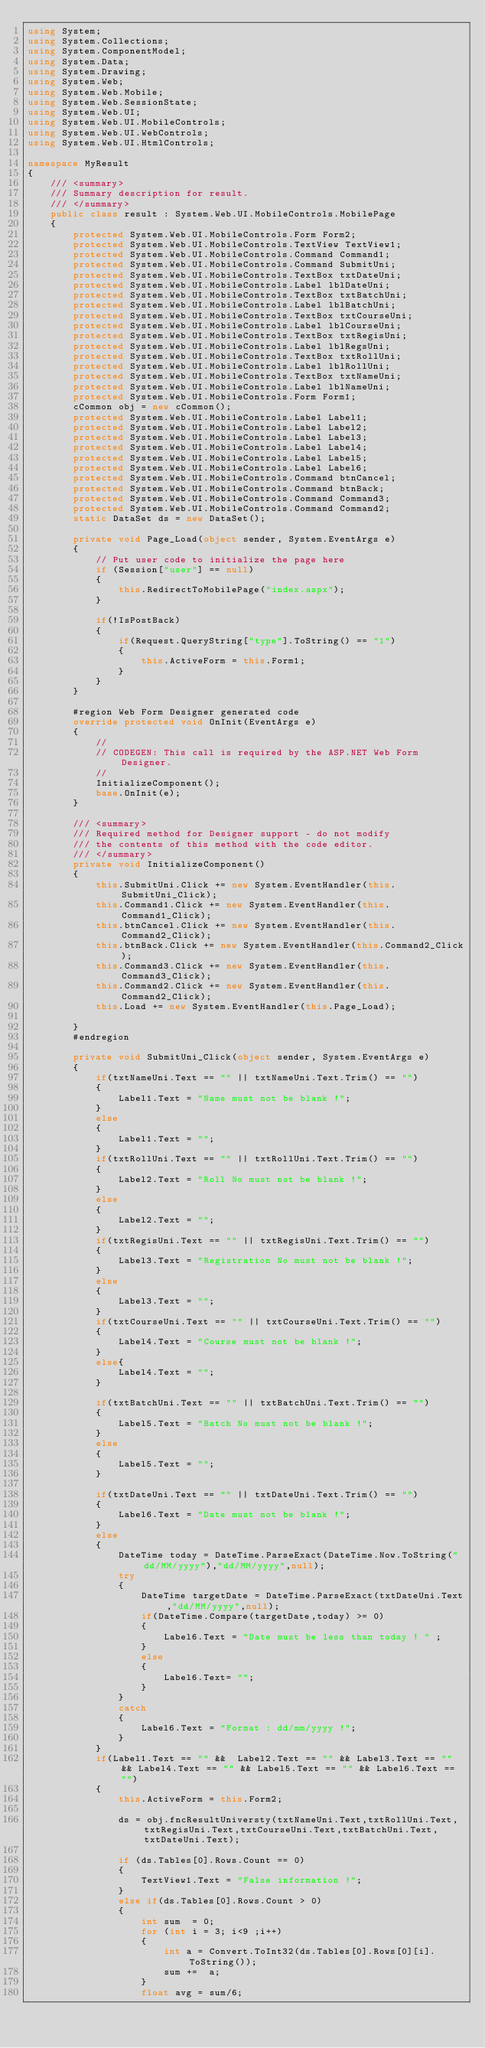<code> <loc_0><loc_0><loc_500><loc_500><_C#_>using System;
using System.Collections;
using System.ComponentModel;
using System.Data;
using System.Drawing;
using System.Web;
using System.Web.Mobile;
using System.Web.SessionState;
using System.Web.UI;
using System.Web.UI.MobileControls;
using System.Web.UI.WebControls;
using System.Web.UI.HtmlControls;

namespace MyResult
{
	/// <summary>
	/// Summary description for result.
	/// </summary>
	public class result : System.Web.UI.MobileControls.MobilePage
	{
		protected System.Web.UI.MobileControls.Form Form2;
		protected System.Web.UI.MobileControls.TextView TextView1;
		protected System.Web.UI.MobileControls.Command Command1;
		protected System.Web.UI.MobileControls.Command SubmitUni;
		protected System.Web.UI.MobileControls.TextBox txtDateUni;
		protected System.Web.UI.MobileControls.Label lblDateUni;
		protected System.Web.UI.MobileControls.TextBox txtBatchUni;
		protected System.Web.UI.MobileControls.Label lblBatchUni;
		protected System.Web.UI.MobileControls.TextBox txtCourseUni;
		protected System.Web.UI.MobileControls.Label lblCourseUni;
		protected System.Web.UI.MobileControls.TextBox txtRegisUni;
		protected System.Web.UI.MobileControls.Label lblRegsUni;
		protected System.Web.UI.MobileControls.TextBox txtRollUni;
		protected System.Web.UI.MobileControls.Label lblRollUni;
		protected System.Web.UI.MobileControls.TextBox txtNameUni;
		protected System.Web.UI.MobileControls.Label lblNameUni;
		protected System.Web.UI.MobileControls.Form Form1;
		cCommon obj = new cCommon();
		protected System.Web.UI.MobileControls.Label Label1;
		protected System.Web.UI.MobileControls.Label Label2;
		protected System.Web.UI.MobileControls.Label Label3;
		protected System.Web.UI.MobileControls.Label Label4;
		protected System.Web.UI.MobileControls.Label Label5;
		protected System.Web.UI.MobileControls.Label Label6;
		protected System.Web.UI.MobileControls.Command btnCancel;
		protected System.Web.UI.MobileControls.Command btnBack;
		protected System.Web.UI.MobileControls.Command Command3;
		protected System.Web.UI.MobileControls.Command Command2;
		static DataSet ds = new DataSet();

		private void Page_Load(object sender, System.EventArgs e)
		{
			// Put user code to initialize the page here
			if (Session["user"] == null)
			{
				this.RedirectToMobilePage("index.aspx");
			}

			if(!IsPostBack)
			{
				if(Request.QueryString["type"].ToString() == "1")
				{
					this.ActiveForm = this.Form1;					
				}
			}			
		}

		#region Web Form Designer generated code
		override protected void OnInit(EventArgs e)
		{
			//
			// CODEGEN: This call is required by the ASP.NET Web Form Designer.
			//
			InitializeComponent();
			base.OnInit(e);
		}

		/// <summary>
		/// Required method for Designer support - do not modify
		/// the contents of this method with the code editor.
		/// </summary>
		private void InitializeComponent()
		{    
			this.SubmitUni.Click += new System.EventHandler(this.SubmitUni_Click);
			this.Command1.Click += new System.EventHandler(this.Command1_Click);
			this.btnCancel.Click += new System.EventHandler(this.Command2_Click);
			this.btnBack.Click += new System.EventHandler(this.Command2_Click);
			this.Command3.Click += new System.EventHandler(this.Command3_Click);
			this.Command2.Click += new System.EventHandler(this.Command2_Click);
			this.Load += new System.EventHandler(this.Page_Load);

		}
		#endregion

		private void SubmitUni_Click(object sender, System.EventArgs e)
		{
			if(txtNameUni.Text == "" || txtNameUni.Text.Trim() == "")
			{
				Label1.Text = "Name must not be blank !";
			}
			else
			{
				Label1.Text = "";
			}
			if(txtRollUni.Text == "" || txtRollUni.Text.Trim() == "")
			{
				Label2.Text = "Roll No must not be blank !";
			}
			else 
			{
				Label2.Text = "";
			}
			if(txtRegisUni.Text == "" || txtRegisUni.Text.Trim() == "")
			{
				Label3.Text = "Registration No must not be blank !";
			}
			else
			{
				Label3.Text = "";
			}
			if(txtCourseUni.Text == "" || txtCourseUni.Text.Trim() == "")
			{
				Label4.Text = "Course must not be blank !";
			}
			else{
				Label4.Text = "";
			} 

			if(txtBatchUni.Text == "" || txtBatchUni.Text.Trim() == "")
			{
				Label5.Text = "Batch No must not be blank !";
			}		
			else
			{
				Label5.Text = "";
			}
			
			if(txtDateUni.Text == "" || txtDateUni.Text.Trim() == "")
			{
				Label6.Text = "Date must not be blank !";
			}
			else
			{
				DateTime today = DateTime.ParseExact(DateTime.Now.ToString("dd/MM/yyyy"),"dd/MM/yyyy",null);
				try
				{
					DateTime targetDate = DateTime.ParseExact(txtDateUni.Text,"dd/MM/yyyy",null);
					if(DateTime.Compare(targetDate,today) >= 0)
					{
						Label6.Text = "Date must be less than today ! "	;
					}
					else
					{
						Label6.Text= "";
					}
				}
				catch
				{
					Label6.Text = "Format : dd/mm/yyyy !";
				}			
			}
			if(Label1.Text == "" &&  Label2.Text == "" && Label3.Text == "" && Label4.Text == "" && Label5.Text == "" && Label6.Text == "")
			{
				this.ActiveForm = this.Form2;	

				ds = obj.fncResultUniversty(txtNameUni.Text,txtRollUni.Text,txtRegisUni.Text,txtCourseUni.Text,txtBatchUni.Text,txtDateUni.Text);
				
				if (ds.Tables[0].Rows.Count == 0)
				{
					TextView1.Text = "False information !";
				}
				else if(ds.Tables[0].Rows.Count > 0)
				{
					int sum  = 0;
					for (int i = 3; i<9 ;i++)
					{
						int a = Convert.ToInt32(ds.Tables[0].Rows[0][i].ToString());
						sum +=  a;
					}
					float avg = sum/6;</code> 